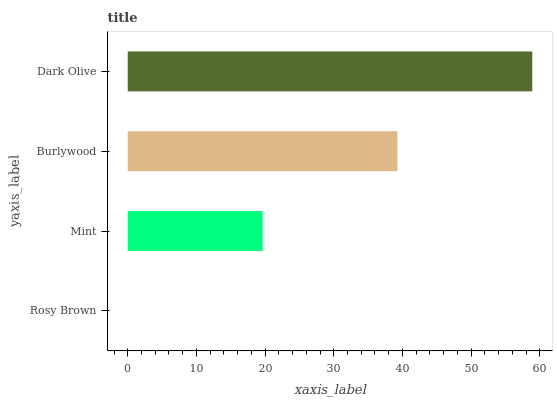Is Rosy Brown the minimum?
Answer yes or no. Yes. Is Dark Olive the maximum?
Answer yes or no. Yes. Is Mint the minimum?
Answer yes or no. No. Is Mint the maximum?
Answer yes or no. No. Is Mint greater than Rosy Brown?
Answer yes or no. Yes. Is Rosy Brown less than Mint?
Answer yes or no. Yes. Is Rosy Brown greater than Mint?
Answer yes or no. No. Is Mint less than Rosy Brown?
Answer yes or no. No. Is Burlywood the high median?
Answer yes or no. Yes. Is Mint the low median?
Answer yes or no. Yes. Is Rosy Brown the high median?
Answer yes or no. No. Is Rosy Brown the low median?
Answer yes or no. No. 